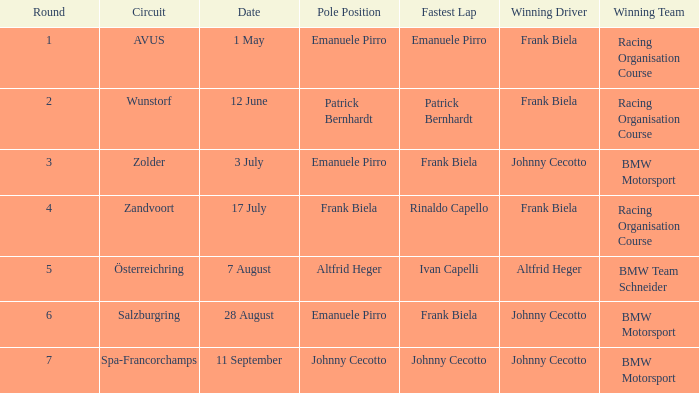What round was circuit Avus? 1.0. 